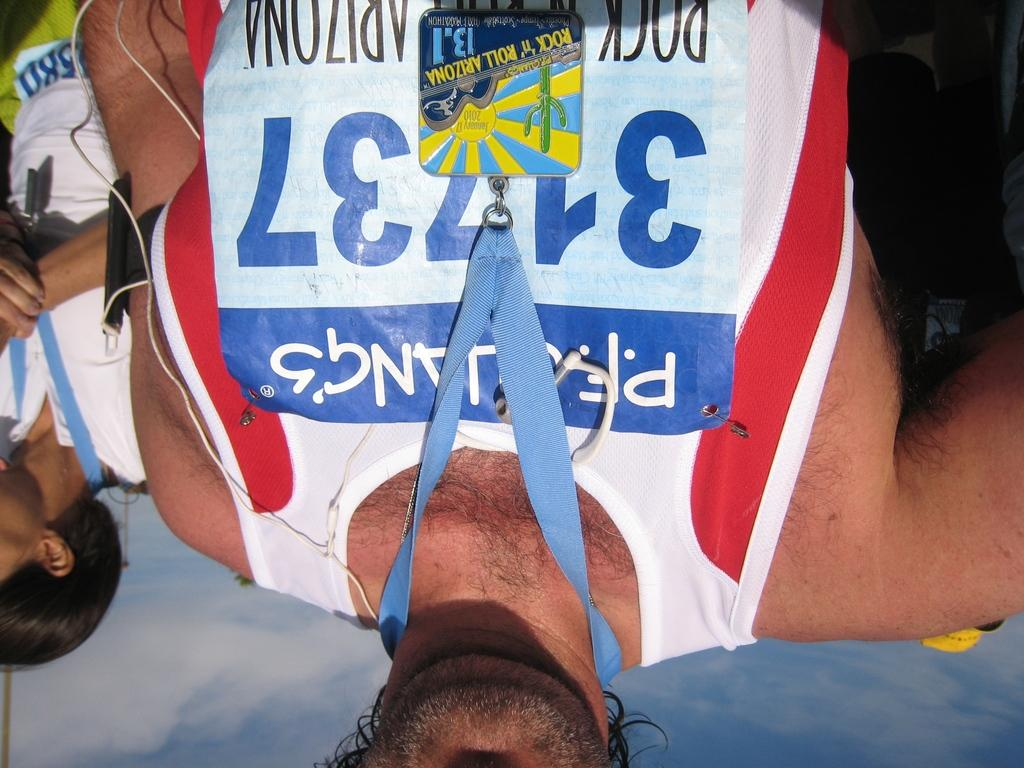<image>
Give a short and clear explanation of the subsequent image. A runner is jogging in a group with a shirt that has the number 31737. 